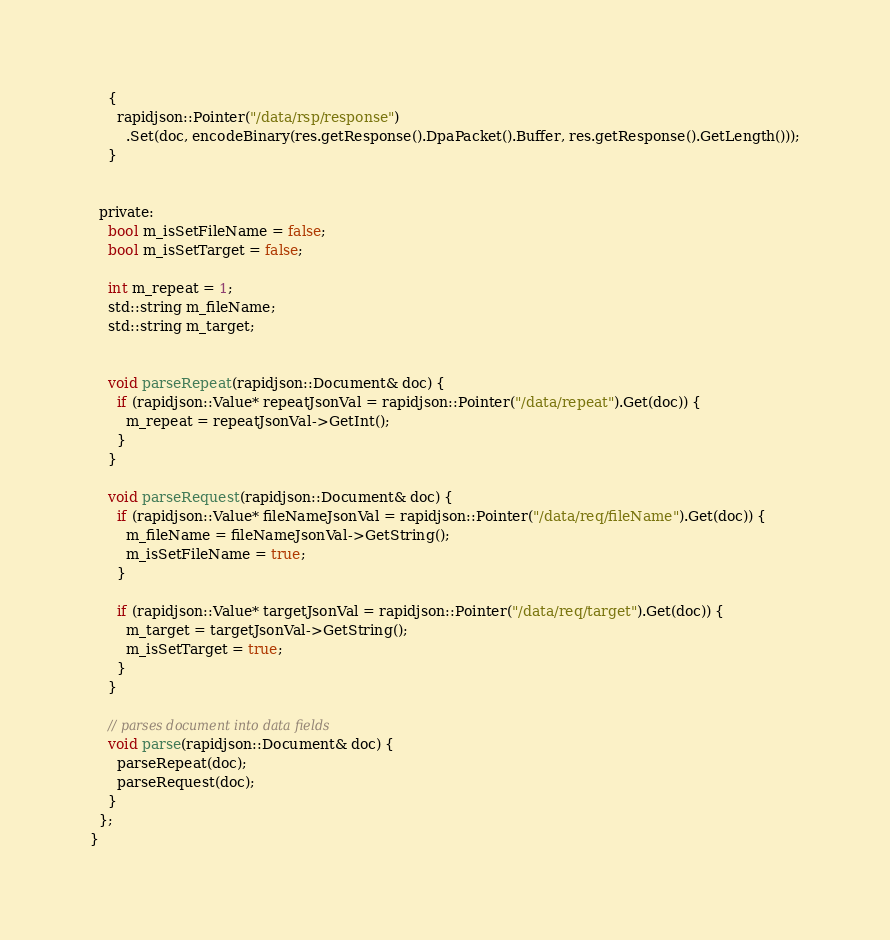Convert code to text. <code><loc_0><loc_0><loc_500><loc_500><_C_>    {
      rapidjson::Pointer("/data/rsp/response")
        .Set(doc, encodeBinary(res.getResponse().DpaPacket().Buffer, res.getResponse().GetLength()));
    }


  private:
    bool m_isSetFileName = false;
    bool m_isSetTarget = false;
    
    int m_repeat = 1;
    std::string m_fileName;
    std::string m_target;
    

    void parseRepeat(rapidjson::Document& doc) {
      if (rapidjson::Value* repeatJsonVal = rapidjson::Pointer("/data/repeat").Get(doc)) {
        m_repeat = repeatJsonVal->GetInt();
      }
    }

    void parseRequest(rapidjson::Document& doc) {
      if (rapidjson::Value* fileNameJsonVal = rapidjson::Pointer("/data/req/fileName").Get(doc)) {
        m_fileName = fileNameJsonVal->GetString();
        m_isSetFileName = true;
      }

      if (rapidjson::Value* targetJsonVal = rapidjson::Pointer("/data/req/target").Get(doc)) {
        m_target = targetJsonVal->GetString();
        m_isSetTarget = true;
      }
    }

    // parses document into data fields
    void parse(rapidjson::Document& doc) {
      parseRepeat(doc);
      parseRequest(doc);
    }
  };
}
</code> 